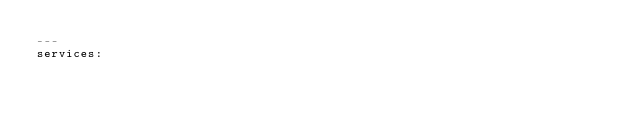Convert code to text. <code><loc_0><loc_0><loc_500><loc_500><_YAML_>---
services:</code> 